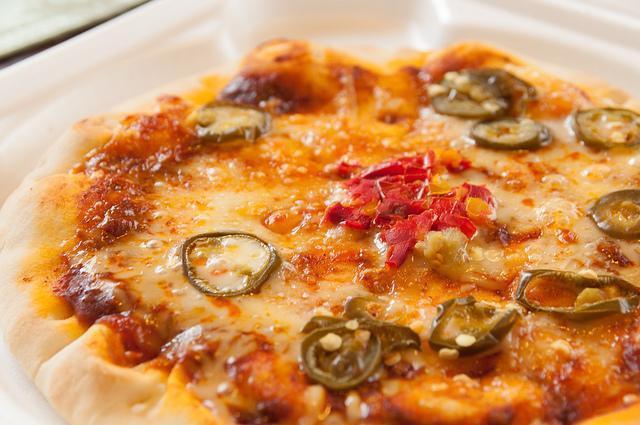How many clock faces are in the shade?
Give a very brief answer. 0. 